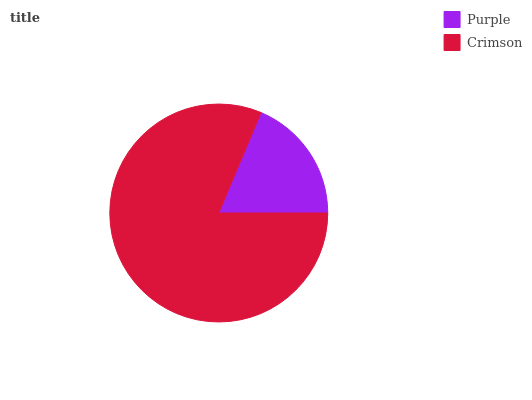Is Purple the minimum?
Answer yes or no. Yes. Is Crimson the maximum?
Answer yes or no. Yes. Is Crimson the minimum?
Answer yes or no. No. Is Crimson greater than Purple?
Answer yes or no. Yes. Is Purple less than Crimson?
Answer yes or no. Yes. Is Purple greater than Crimson?
Answer yes or no. No. Is Crimson less than Purple?
Answer yes or no. No. Is Crimson the high median?
Answer yes or no. Yes. Is Purple the low median?
Answer yes or no. Yes. Is Purple the high median?
Answer yes or no. No. Is Crimson the low median?
Answer yes or no. No. 